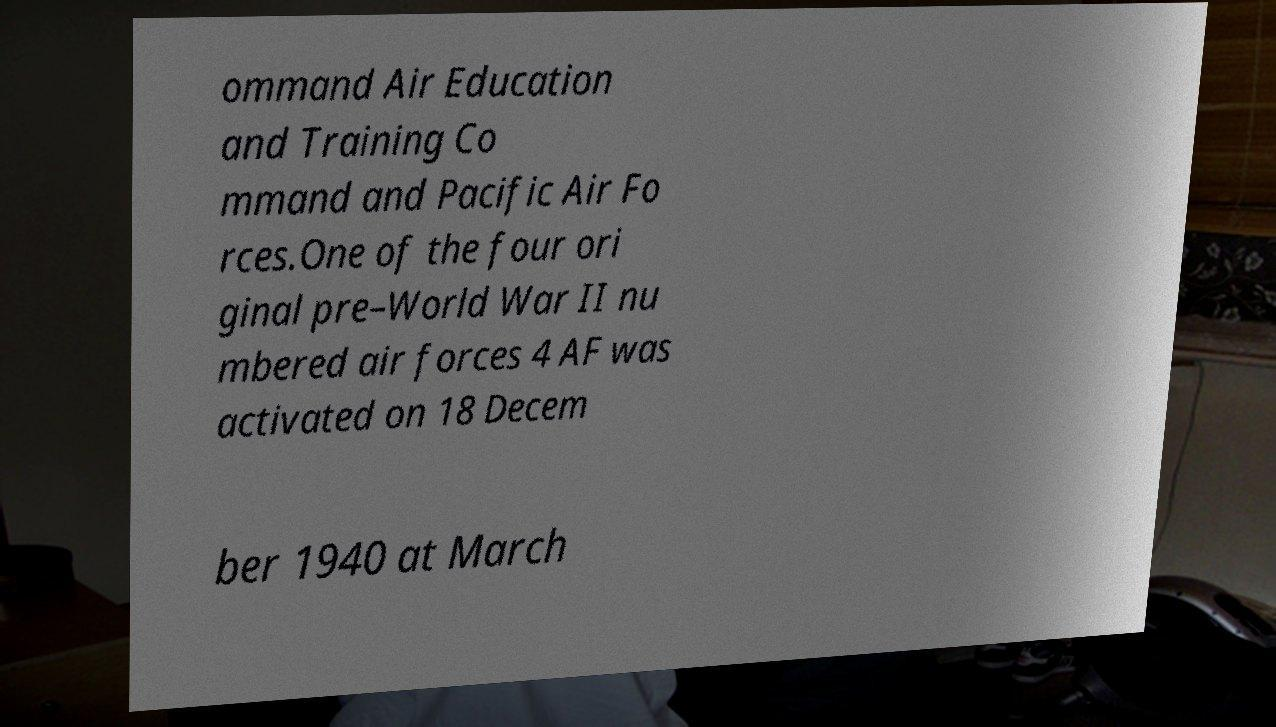Could you extract and type out the text from this image? ommand Air Education and Training Co mmand and Pacific Air Fo rces.One of the four ori ginal pre–World War II nu mbered air forces 4 AF was activated on 18 Decem ber 1940 at March 